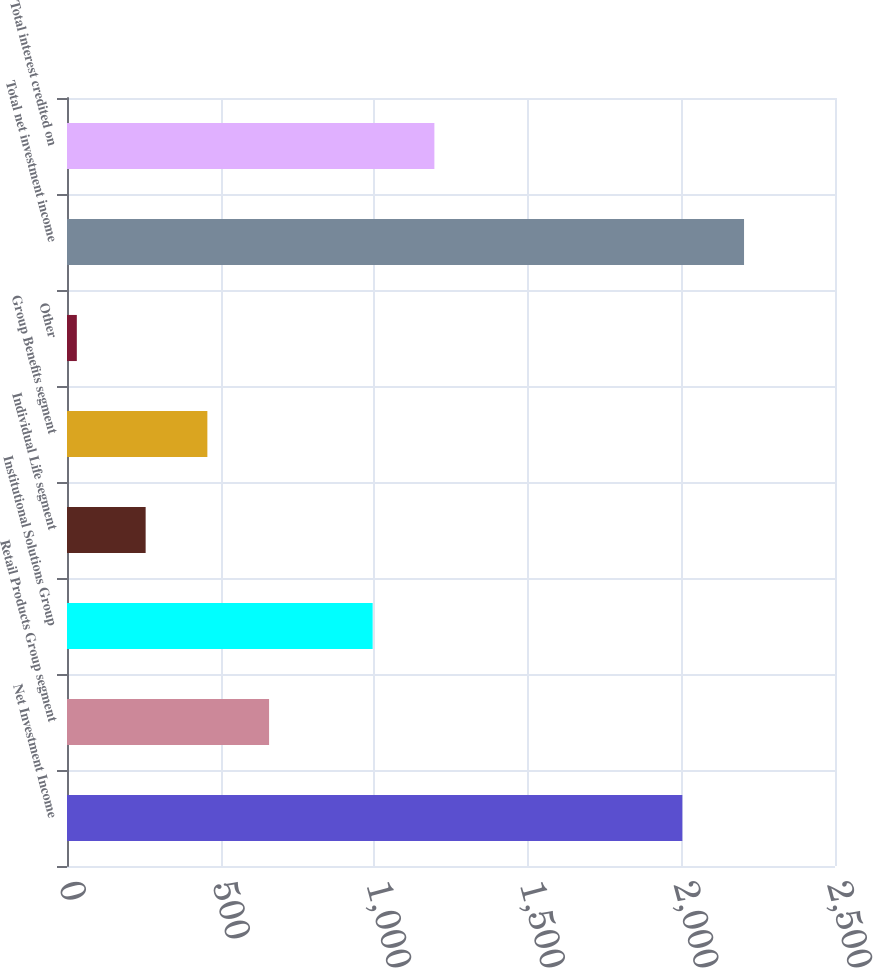Convert chart to OTSL. <chart><loc_0><loc_0><loc_500><loc_500><bar_chart><fcel>Net Investment Income<fcel>Retail Products Group segment<fcel>Institutional Solutions Group<fcel>Individual Life segment<fcel>Group Benefits segment<fcel>Other<fcel>Total net investment income<fcel>Total interest credited on<nl><fcel>2003<fcel>657.8<fcel>995<fcel>256<fcel>456.9<fcel>32<fcel>2203.9<fcel>1195.9<nl></chart> 